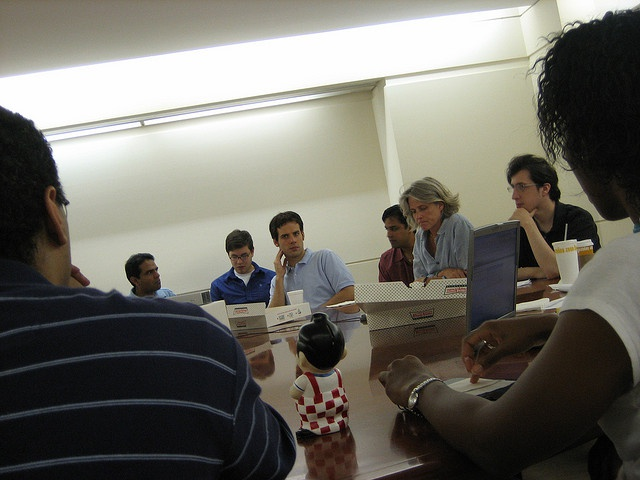Describe the objects in this image and their specific colors. I can see people in gray, black, and maroon tones, people in gray, black, and darkgray tones, people in gray, black, and maroon tones, people in gray, black, and maroon tones, and people in gray, maroon, and darkgray tones in this image. 